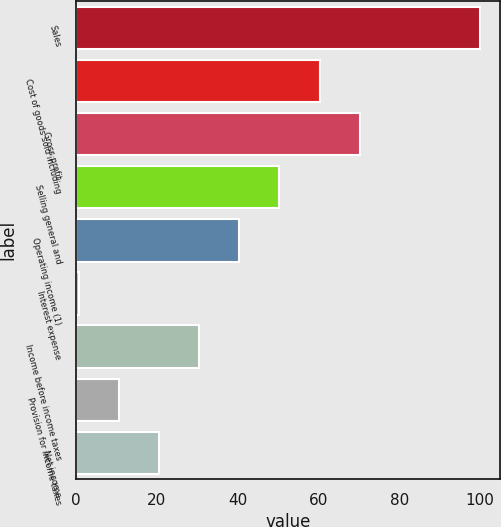Convert chart to OTSL. <chart><loc_0><loc_0><loc_500><loc_500><bar_chart><fcel>Sales<fcel>Cost of goods sold including<fcel>Gross profit<fcel>Selling general and<fcel>Operating income (1)<fcel>Interest expense<fcel>Income before income taxes<fcel>Provision for income taxes<fcel>Net income<nl><fcel>100<fcel>60.32<fcel>70.24<fcel>50.4<fcel>40.48<fcel>0.8<fcel>30.56<fcel>10.72<fcel>20.64<nl></chart> 